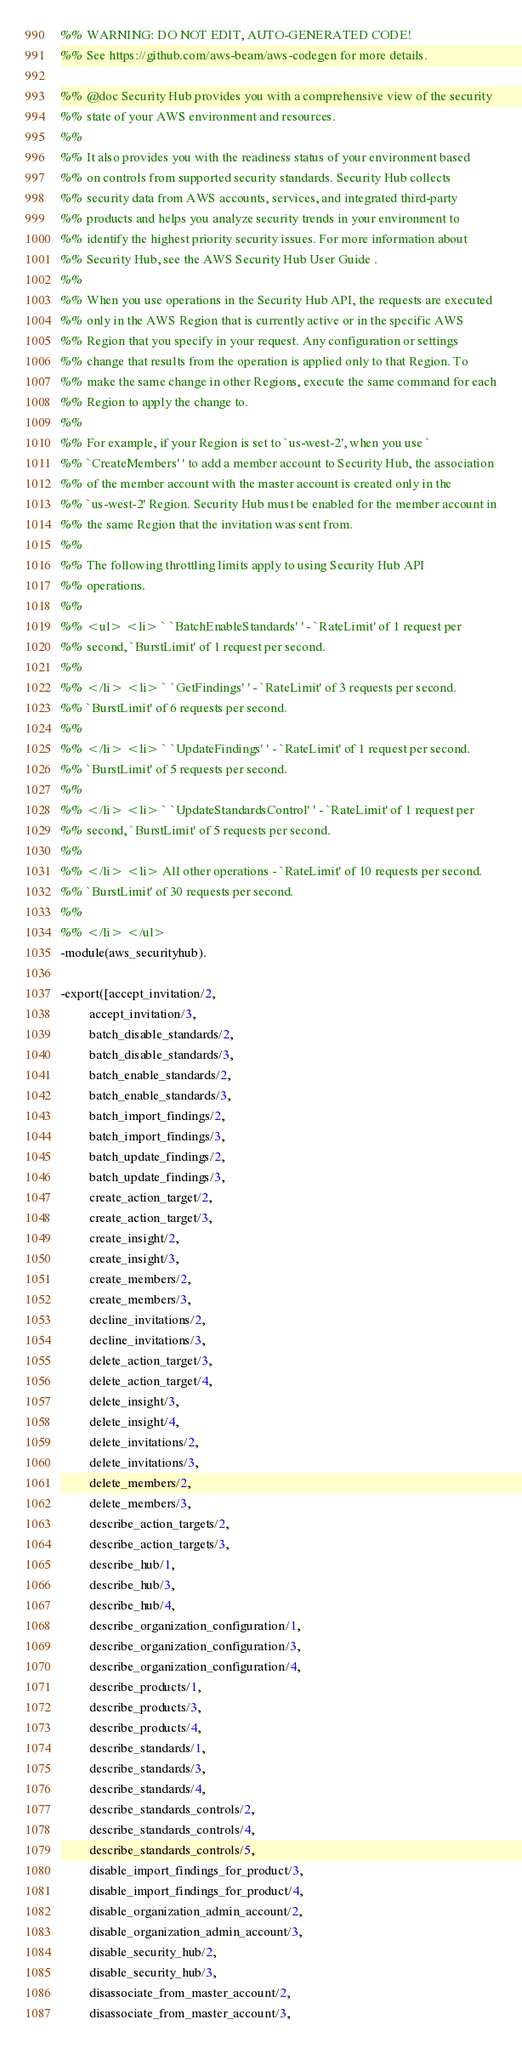Convert code to text. <code><loc_0><loc_0><loc_500><loc_500><_Erlang_>%% WARNING: DO NOT EDIT, AUTO-GENERATED CODE!
%% See https://github.com/aws-beam/aws-codegen for more details.

%% @doc Security Hub provides you with a comprehensive view of the security
%% state of your AWS environment and resources.
%%
%% It also provides you with the readiness status of your environment based
%% on controls from supported security standards. Security Hub collects
%% security data from AWS accounts, services, and integrated third-party
%% products and helps you analyze security trends in your environment to
%% identify the highest priority security issues. For more information about
%% Security Hub, see the AWS Security Hub User Guide .
%%
%% When you use operations in the Security Hub API, the requests are executed
%% only in the AWS Region that is currently active or in the specific AWS
%% Region that you specify in your request. Any configuration or settings
%% change that results from the operation is applied only to that Region. To
%% make the same change in other Regions, execute the same command for each
%% Region to apply the change to.
%%
%% For example, if your Region is set to `us-west-2', when you use `
%% `CreateMembers' ' to add a member account to Security Hub, the association
%% of the member account with the master account is created only in the
%% `us-west-2' Region. Security Hub must be enabled for the member account in
%% the same Region that the invitation was sent from.
%%
%% The following throttling limits apply to using Security Hub API
%% operations.
%%
%% <ul> <li> ` `BatchEnableStandards' ' - `RateLimit' of 1 request per
%% second, `BurstLimit' of 1 request per second.
%%
%% </li> <li> ` `GetFindings' ' - `RateLimit' of 3 requests per second.
%% `BurstLimit' of 6 requests per second.
%%
%% </li> <li> ` `UpdateFindings' ' - `RateLimit' of 1 request per second.
%% `BurstLimit' of 5 requests per second.
%%
%% </li> <li> ` `UpdateStandardsControl' ' - `RateLimit' of 1 request per
%% second, `BurstLimit' of 5 requests per second.
%%
%% </li> <li> All other operations - `RateLimit' of 10 requests per second.
%% `BurstLimit' of 30 requests per second.
%%
%% </li> </ul>
-module(aws_securityhub).

-export([accept_invitation/2,
         accept_invitation/3,
         batch_disable_standards/2,
         batch_disable_standards/3,
         batch_enable_standards/2,
         batch_enable_standards/3,
         batch_import_findings/2,
         batch_import_findings/3,
         batch_update_findings/2,
         batch_update_findings/3,
         create_action_target/2,
         create_action_target/3,
         create_insight/2,
         create_insight/3,
         create_members/2,
         create_members/3,
         decline_invitations/2,
         decline_invitations/3,
         delete_action_target/3,
         delete_action_target/4,
         delete_insight/3,
         delete_insight/4,
         delete_invitations/2,
         delete_invitations/3,
         delete_members/2,
         delete_members/3,
         describe_action_targets/2,
         describe_action_targets/3,
         describe_hub/1,
         describe_hub/3,
         describe_hub/4,
         describe_organization_configuration/1,
         describe_organization_configuration/3,
         describe_organization_configuration/4,
         describe_products/1,
         describe_products/3,
         describe_products/4,
         describe_standards/1,
         describe_standards/3,
         describe_standards/4,
         describe_standards_controls/2,
         describe_standards_controls/4,
         describe_standards_controls/5,
         disable_import_findings_for_product/3,
         disable_import_findings_for_product/4,
         disable_organization_admin_account/2,
         disable_organization_admin_account/3,
         disable_security_hub/2,
         disable_security_hub/3,
         disassociate_from_master_account/2,
         disassociate_from_master_account/3,</code> 